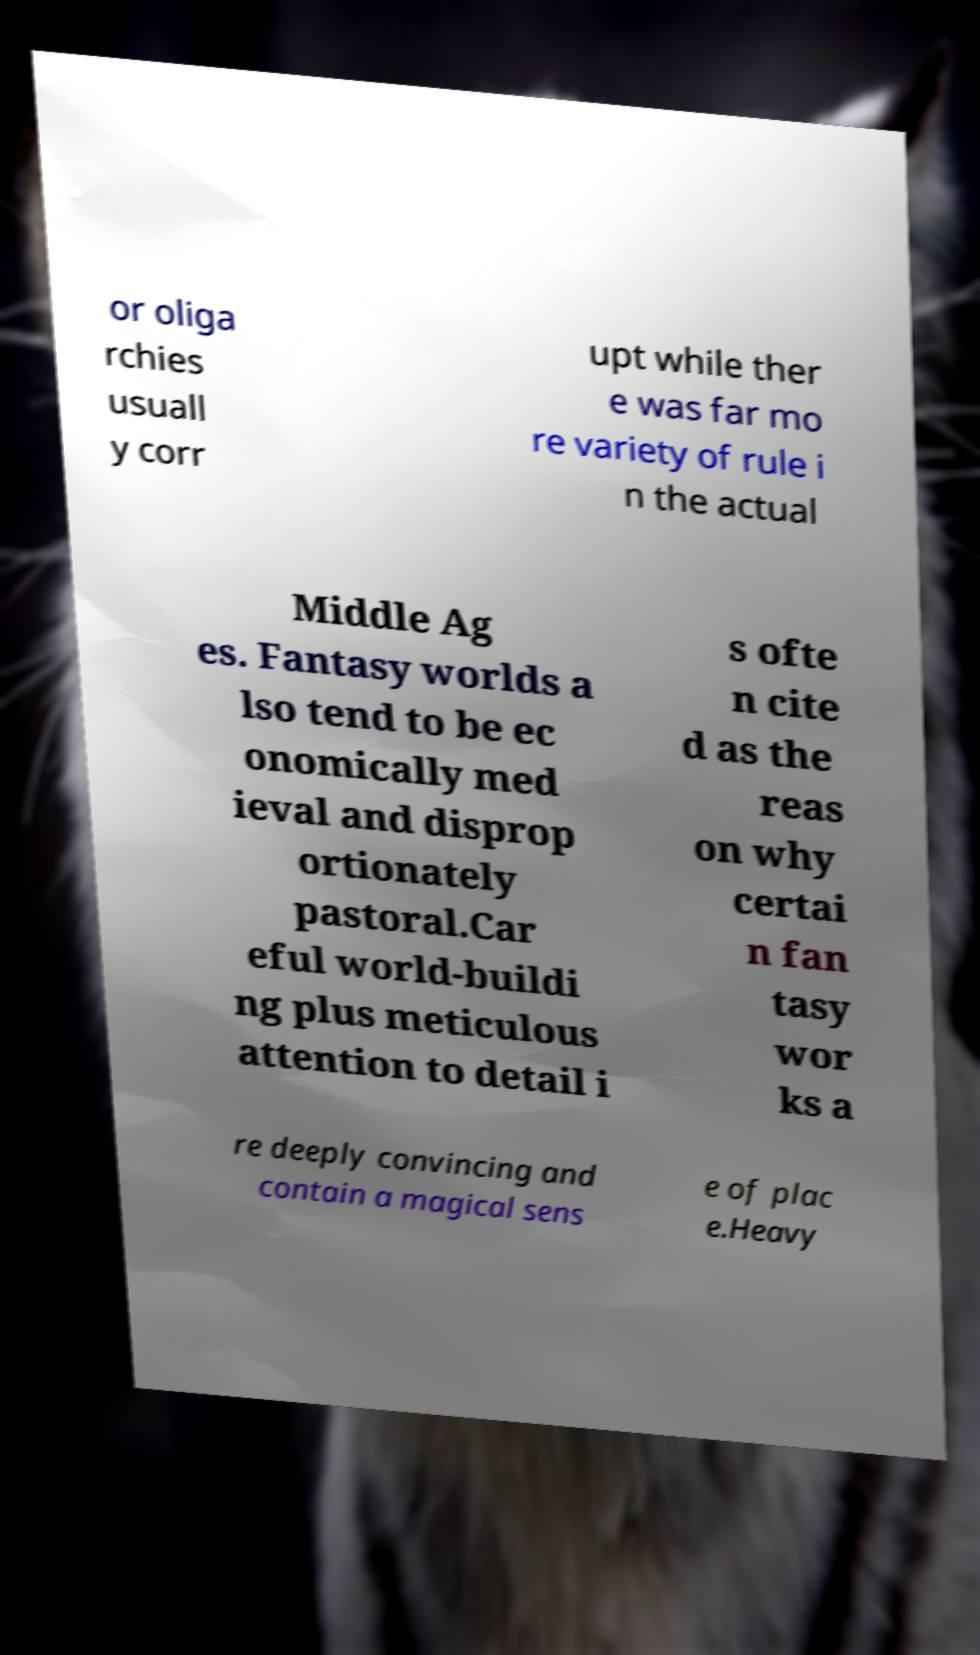Can you accurately transcribe the text from the provided image for me? or oliga rchies usuall y corr upt while ther e was far mo re variety of rule i n the actual Middle Ag es. Fantasy worlds a lso tend to be ec onomically med ieval and disprop ortionately pastoral.Car eful world-buildi ng plus meticulous attention to detail i s ofte n cite d as the reas on why certai n fan tasy wor ks a re deeply convincing and contain a magical sens e of plac e.Heavy 